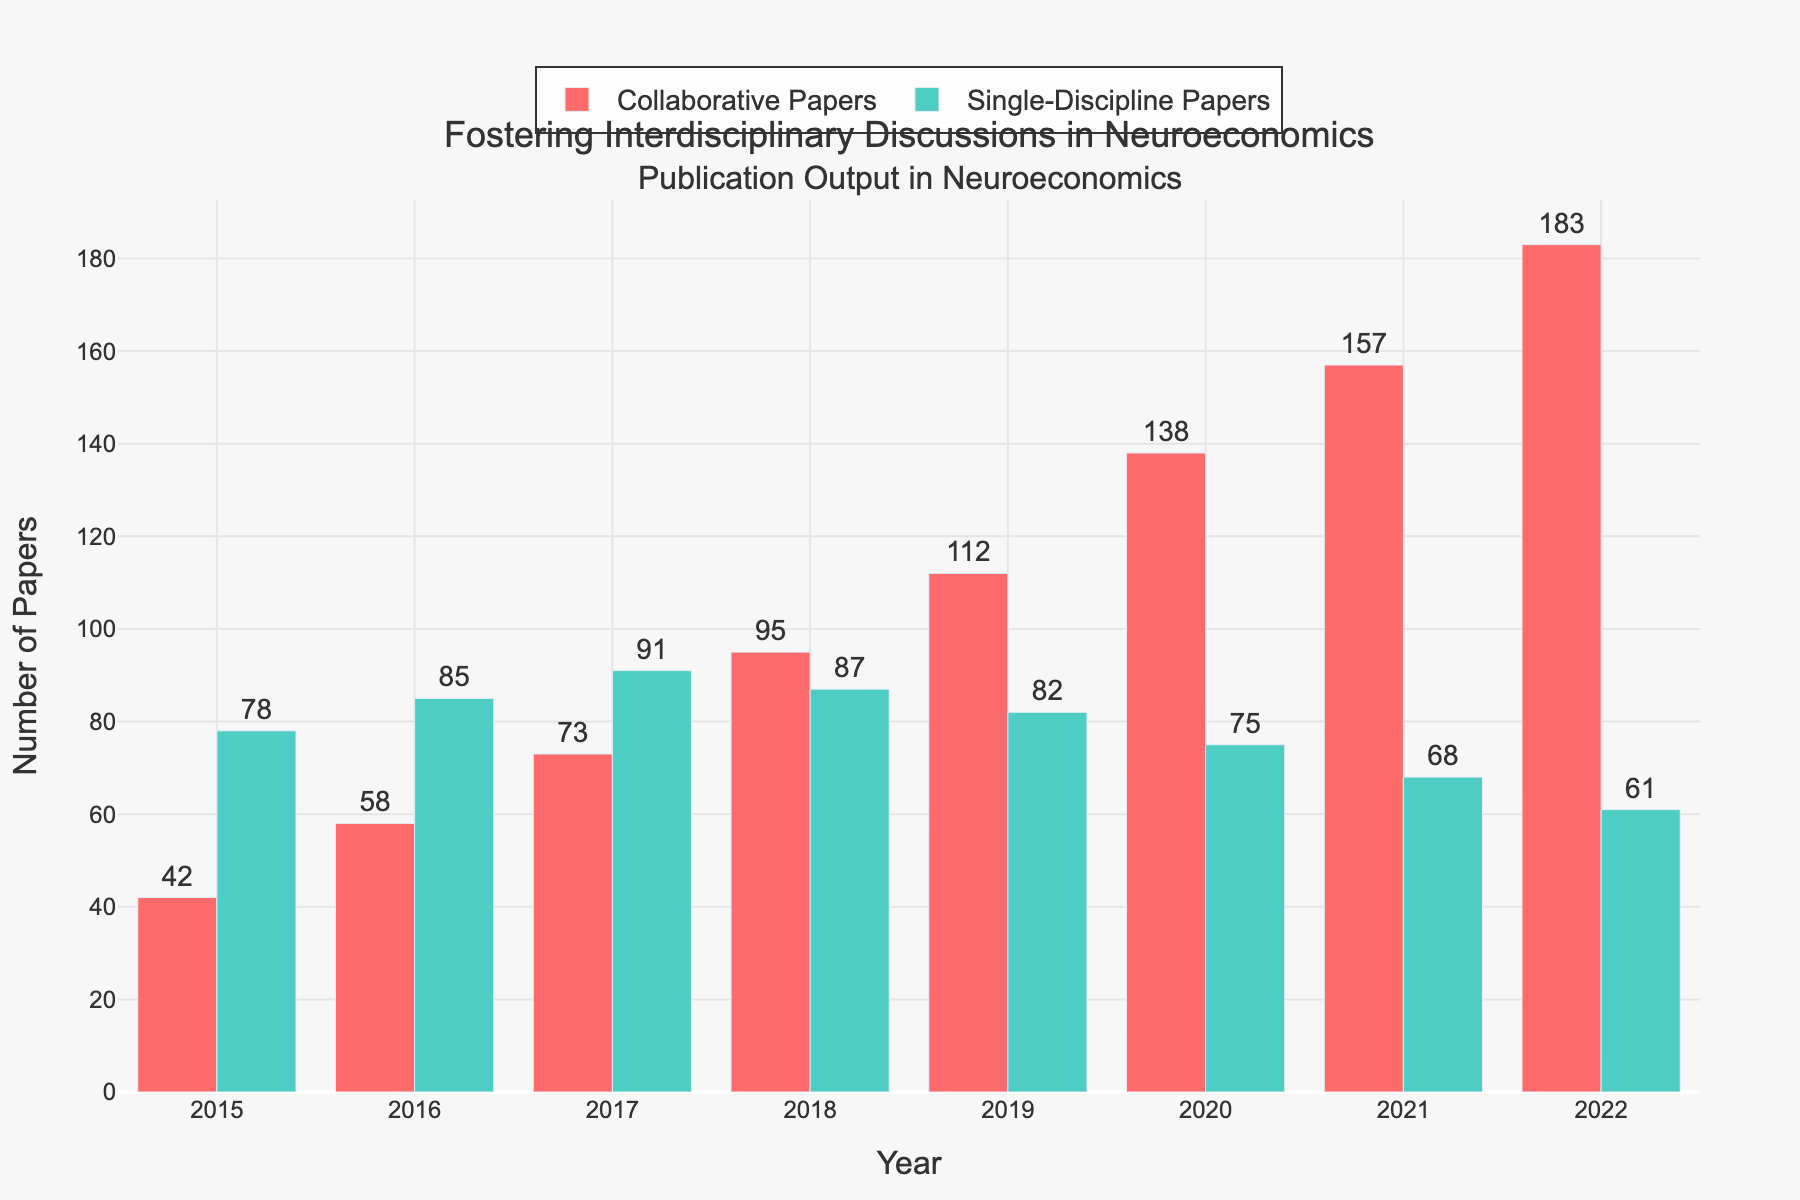What is the trend in the number of collaborative papers from 2015 to 2022? The number of collaborative papers shows a clear increasing trend from 42 in 2015 to 183 in 2022. This can be seen as the height of the red bars increases each year.
Answer: Increasing In which year was the number of single-discipline papers highest? By comparing the heights of all the turquoise bars, the tallest bar is in 2017, indicating that the highest number of single-discipline papers was published in that year.
Answer: 2017 What is the difference in the number of collaborative and single-discipline papers in 2022? The number of collaborative papers in 2022 is 183 and the number of single-discipline papers is 61. The difference is calculated as 183 - 61 = 122.
Answer: 122 Which color represents the collaborative papers, and which represents the single-discipline papers? Collaborative papers are represented by the red bars, and single-discipline papers are represented by the turquoise bars.
Answer: Red, Turquoise What is the total number of papers published (collaborative and single-discipline) in 2020? The number of collaborative papers in 2020 is 138 and single-discipline papers is 75. The total number of papers is 138 + 75 = 213.
Answer: 213 How did the number of single-discipline papers change from 2015 to 2022? By observing the heights of the turquoise bars, there is a decreasing trend in the number of single-discipline papers from 78 in 2015 to 61 in 2022.
Answer: Decreasing In which year were the numbers of collaborative and single-discipline papers closest to each other? By comparing the heights of the red and turquoise bars year by year, in 2018, the number of collaborative papers (95) and single-discipline papers (87) are closest, with a difference of just 8.
Answer: 2018 What was the percentage increase in collaborative papers from 2015 to 2022? The number of collaborative papers increased from 42 in 2015 to 183 in 2022. The percentage increase is calculated as ((183 - 42) / 42) * 100 = 335.71%.
Answer: 335.71% What is the average number of single-discipline papers published per year between 2015 and 2022? Sum the number of single-discipline papers from 2015 to 2022 and divide by the number of years: (78 + 85 + 91 + 87 + 82 + 75 + 68 + 61) / 8 = 627 / 8 = 78.375.
Answer: 78.375 In which year did collaborative papers overtake single-discipline papers in number for the first time? Comparing the red and turquoise bars, collaborative papers first overtook single-discipline papers in number in 2018, where the red bar for collaborative papers (95) is taller than the turquoise bar for single-discipline papers (87).
Answer: 2018 